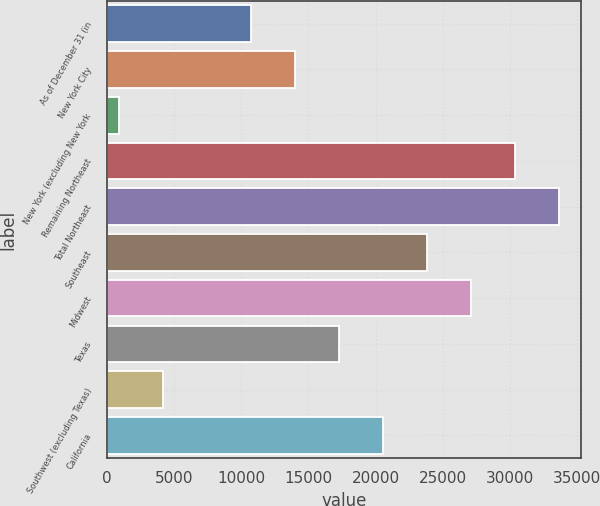Convert chart. <chart><loc_0><loc_0><loc_500><loc_500><bar_chart><fcel>As of December 31 (in<fcel>New York City<fcel>New York (excluding New York<fcel>Remaining Northeast<fcel>Total Northeast<fcel>Southeast<fcel>Midwest<fcel>Texas<fcel>Southwest (excluding Texas)<fcel>California<nl><fcel>10739.7<fcel>14007.6<fcel>936<fcel>30347.1<fcel>33615<fcel>23811.3<fcel>27079.2<fcel>17275.5<fcel>4203.9<fcel>20543.4<nl></chart> 